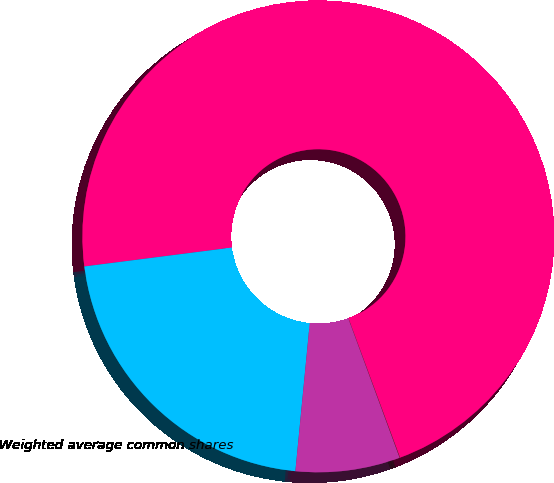Convert chart to OTSL. <chart><loc_0><loc_0><loc_500><loc_500><pie_chart><fcel>(In millions)<fcel>Weighted average common shares<fcel>Dilutive effect of stock<fcel>Antidilutive stock options<nl><fcel>71.38%<fcel>21.43%<fcel>7.16%<fcel>0.02%<nl></chart> 